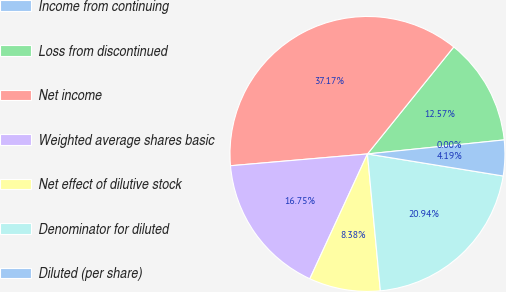Convert chart to OTSL. <chart><loc_0><loc_0><loc_500><loc_500><pie_chart><fcel>Income from continuing<fcel>Loss from discontinued<fcel>Net income<fcel>Weighted average shares basic<fcel>Net effect of dilutive stock<fcel>Denominator for diluted<fcel>Diluted (per share)<nl><fcel>0.0%<fcel>12.57%<fcel>37.17%<fcel>16.75%<fcel>8.38%<fcel>20.94%<fcel>4.19%<nl></chart> 